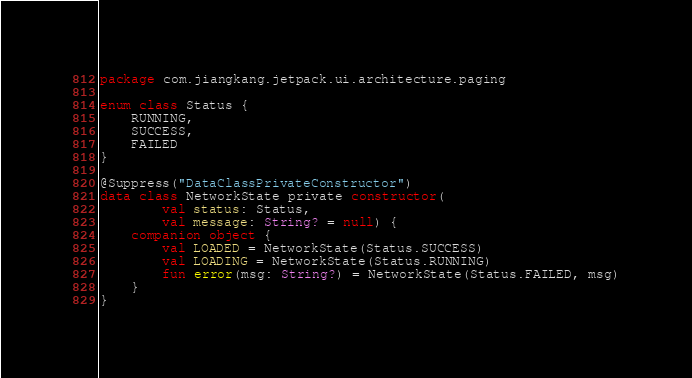<code> <loc_0><loc_0><loc_500><loc_500><_Kotlin_>package com.jiangkang.jetpack.ui.architecture.paging

enum class Status {
    RUNNING,
    SUCCESS,
    FAILED
}

@Suppress("DataClassPrivateConstructor")
data class NetworkState private constructor(
        val status: Status,
        val message: String? = null) {
    companion object {
        val LOADED = NetworkState(Status.SUCCESS)
        val LOADING = NetworkState(Status.RUNNING)
        fun error(msg: String?) = NetworkState(Status.FAILED, msg)
    }
}</code> 